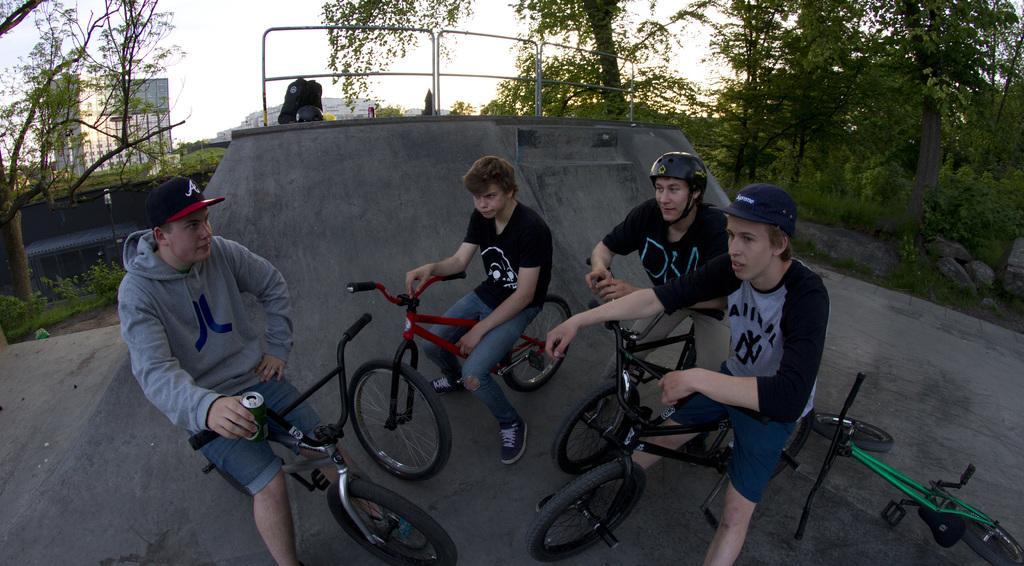Describe this image in one or two sentences. In this image there is a group of four person sitting on a bicycle near to a structure. On above a structure there is a helmet, bag and coke can. On the right side we can see a trees, stones and a sky. On the background we can see a building. On the bottom right corner there is a green bicycle which lying on the floor. 